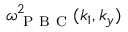Convert formula to latex. <formula><loc_0><loc_0><loc_500><loc_500>\omega _ { P B C } ^ { 2 } ( k _ { 1 } , k _ { y } )</formula> 